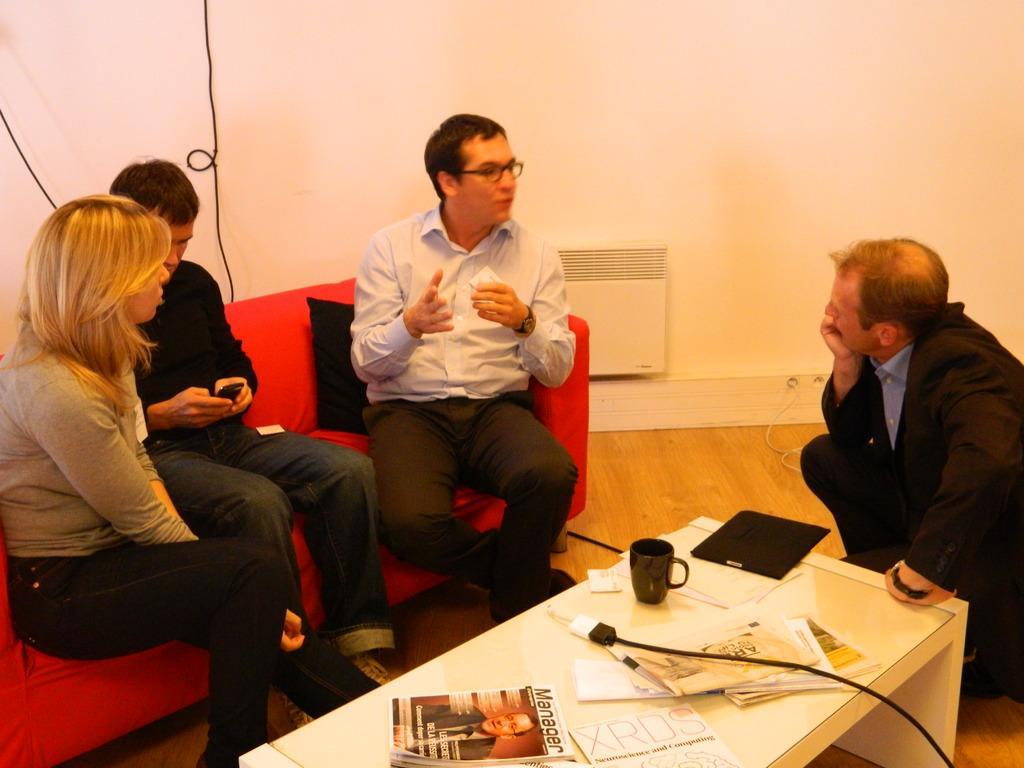How would you summarize this image in a sentence or two? There are two men and one women sitting on the couch. Here is another man sitting in squat position. This is a table with a magazine,cup,cable,newspaper and few objects on it. The couch i red in color. Here is a black color cushion on the couch. This is the wall. Here is a white color object attached to the wall. This is the wooden floor. 